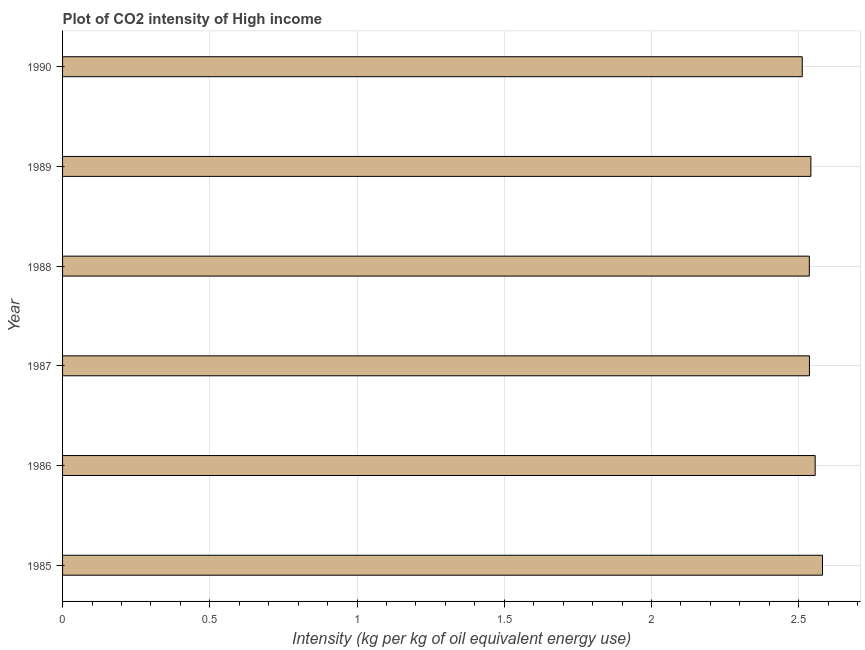Does the graph contain grids?
Your answer should be very brief. Yes. What is the title of the graph?
Provide a short and direct response. Plot of CO2 intensity of High income. What is the label or title of the X-axis?
Your answer should be very brief. Intensity (kg per kg of oil equivalent energy use). What is the co2 intensity in 1986?
Your response must be concise. 2.56. Across all years, what is the maximum co2 intensity?
Make the answer very short. 2.58. Across all years, what is the minimum co2 intensity?
Your answer should be compact. 2.51. In which year was the co2 intensity maximum?
Provide a succinct answer. 1985. What is the sum of the co2 intensity?
Make the answer very short. 15.26. What is the difference between the co2 intensity in 1986 and 1987?
Ensure brevity in your answer.  0.02. What is the average co2 intensity per year?
Provide a succinct answer. 2.54. What is the median co2 intensity?
Offer a very short reply. 2.54. Is the co2 intensity in 1988 less than that in 1990?
Ensure brevity in your answer.  No. Is the difference between the co2 intensity in 1986 and 1988 greater than the difference between any two years?
Make the answer very short. No. What is the difference between the highest and the second highest co2 intensity?
Offer a very short reply. 0.03. Is the sum of the co2 intensity in 1987 and 1990 greater than the maximum co2 intensity across all years?
Make the answer very short. Yes. What is the difference between the highest and the lowest co2 intensity?
Your answer should be very brief. 0.07. In how many years, is the co2 intensity greater than the average co2 intensity taken over all years?
Offer a very short reply. 2. How many bars are there?
Offer a terse response. 6. How many years are there in the graph?
Provide a short and direct response. 6. What is the difference between two consecutive major ticks on the X-axis?
Your answer should be very brief. 0.5. Are the values on the major ticks of X-axis written in scientific E-notation?
Your answer should be compact. No. What is the Intensity (kg per kg of oil equivalent energy use) of 1985?
Your answer should be very brief. 2.58. What is the Intensity (kg per kg of oil equivalent energy use) in 1986?
Make the answer very short. 2.56. What is the Intensity (kg per kg of oil equivalent energy use) in 1987?
Make the answer very short. 2.54. What is the Intensity (kg per kg of oil equivalent energy use) in 1988?
Your answer should be very brief. 2.54. What is the Intensity (kg per kg of oil equivalent energy use) of 1989?
Give a very brief answer. 2.54. What is the Intensity (kg per kg of oil equivalent energy use) of 1990?
Provide a short and direct response. 2.51. What is the difference between the Intensity (kg per kg of oil equivalent energy use) in 1985 and 1986?
Keep it short and to the point. 0.02. What is the difference between the Intensity (kg per kg of oil equivalent energy use) in 1985 and 1987?
Provide a succinct answer. 0.04. What is the difference between the Intensity (kg per kg of oil equivalent energy use) in 1985 and 1988?
Your answer should be compact. 0.04. What is the difference between the Intensity (kg per kg of oil equivalent energy use) in 1985 and 1989?
Make the answer very short. 0.04. What is the difference between the Intensity (kg per kg of oil equivalent energy use) in 1985 and 1990?
Your response must be concise. 0.07. What is the difference between the Intensity (kg per kg of oil equivalent energy use) in 1986 and 1987?
Ensure brevity in your answer.  0.02. What is the difference between the Intensity (kg per kg of oil equivalent energy use) in 1986 and 1988?
Offer a very short reply. 0.02. What is the difference between the Intensity (kg per kg of oil equivalent energy use) in 1986 and 1989?
Provide a succinct answer. 0.01. What is the difference between the Intensity (kg per kg of oil equivalent energy use) in 1986 and 1990?
Offer a very short reply. 0.04. What is the difference between the Intensity (kg per kg of oil equivalent energy use) in 1987 and 1988?
Provide a short and direct response. 0. What is the difference between the Intensity (kg per kg of oil equivalent energy use) in 1987 and 1989?
Offer a very short reply. -0. What is the difference between the Intensity (kg per kg of oil equivalent energy use) in 1987 and 1990?
Your answer should be compact. 0.02. What is the difference between the Intensity (kg per kg of oil equivalent energy use) in 1988 and 1989?
Offer a very short reply. -0.01. What is the difference between the Intensity (kg per kg of oil equivalent energy use) in 1988 and 1990?
Make the answer very short. 0.02. What is the difference between the Intensity (kg per kg of oil equivalent energy use) in 1989 and 1990?
Keep it short and to the point. 0.03. What is the ratio of the Intensity (kg per kg of oil equivalent energy use) in 1985 to that in 1986?
Your response must be concise. 1.01. What is the ratio of the Intensity (kg per kg of oil equivalent energy use) in 1985 to that in 1989?
Provide a short and direct response. 1.02. What is the ratio of the Intensity (kg per kg of oil equivalent energy use) in 1986 to that in 1988?
Keep it short and to the point. 1.01. What is the ratio of the Intensity (kg per kg of oil equivalent energy use) in 1986 to that in 1990?
Offer a very short reply. 1.02. What is the ratio of the Intensity (kg per kg of oil equivalent energy use) in 1987 to that in 1988?
Ensure brevity in your answer.  1. What is the ratio of the Intensity (kg per kg of oil equivalent energy use) in 1987 to that in 1990?
Provide a succinct answer. 1.01. What is the ratio of the Intensity (kg per kg of oil equivalent energy use) in 1989 to that in 1990?
Keep it short and to the point. 1.01. 